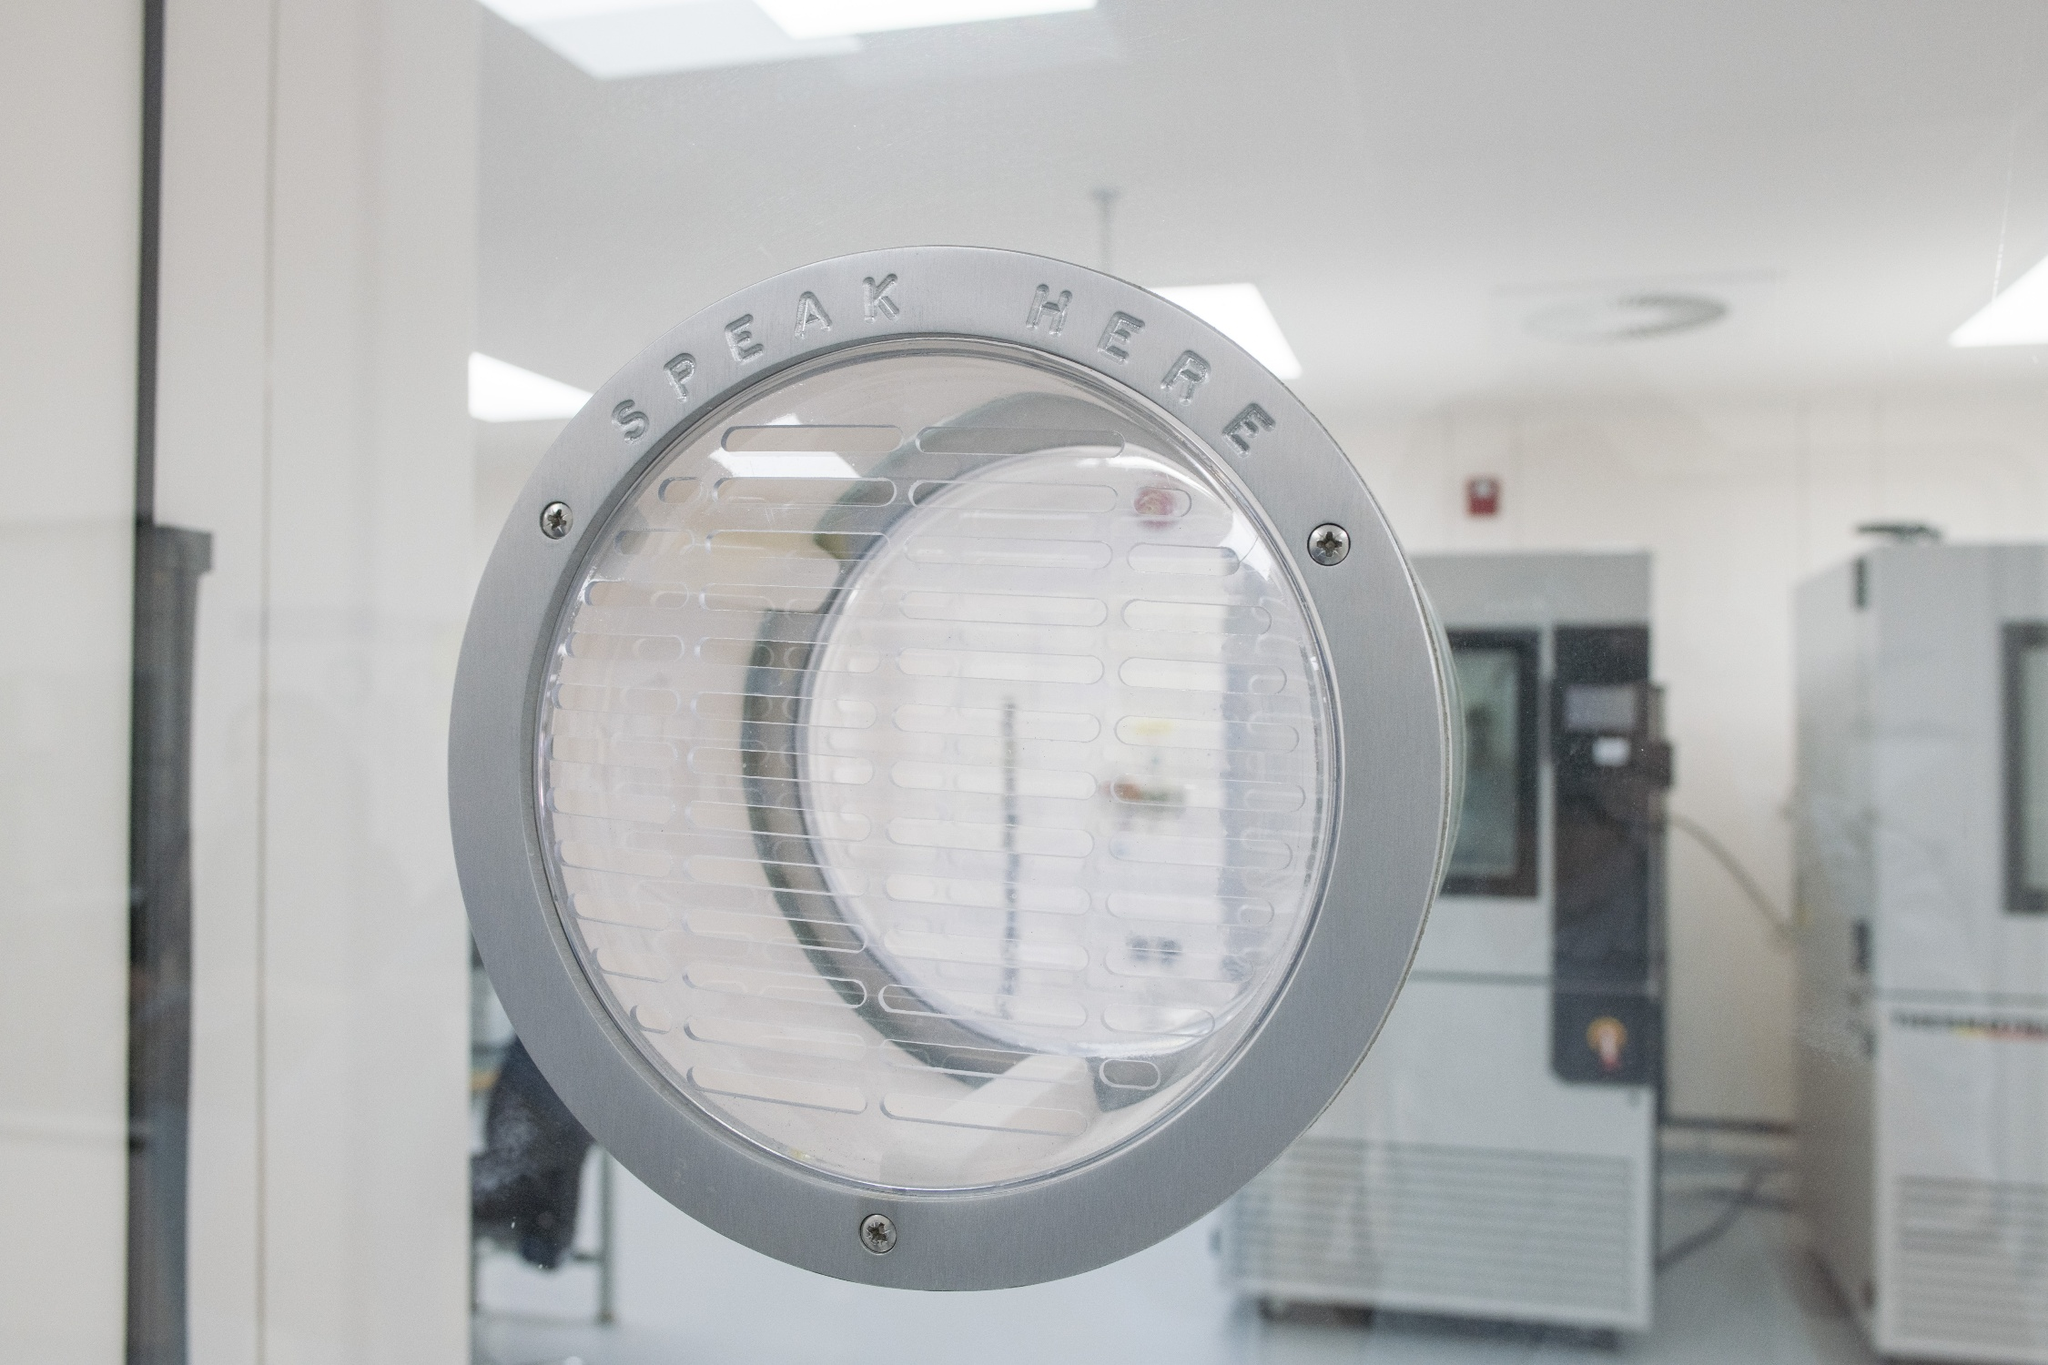What do you see happening in this image? The image displays a close-up view of a round, silver-colored metal intercom speaker, prominently mounted on a white wall. The speaker, slightly off-center to the left, clearly bears the instruction 'SPEAK HERE' engraved at the top. The background, though subtly blurred, suggests a professional or institutional environment, possibly a laboratory or a controlled facility, with white walls and gray equipment visible. The contrasting colors emphasize the speaker's importance in facilitating communication within this space. 